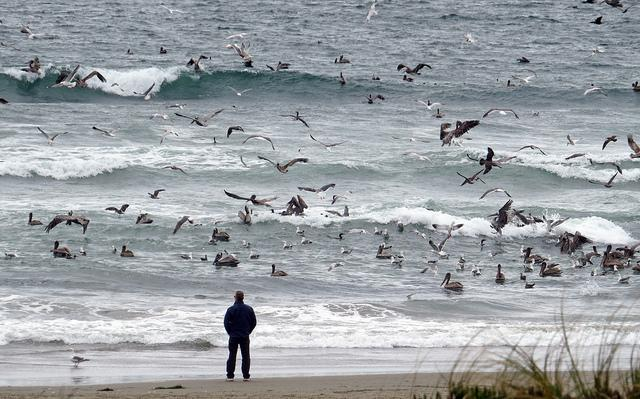What is the most diverse seashore bird? seagull 